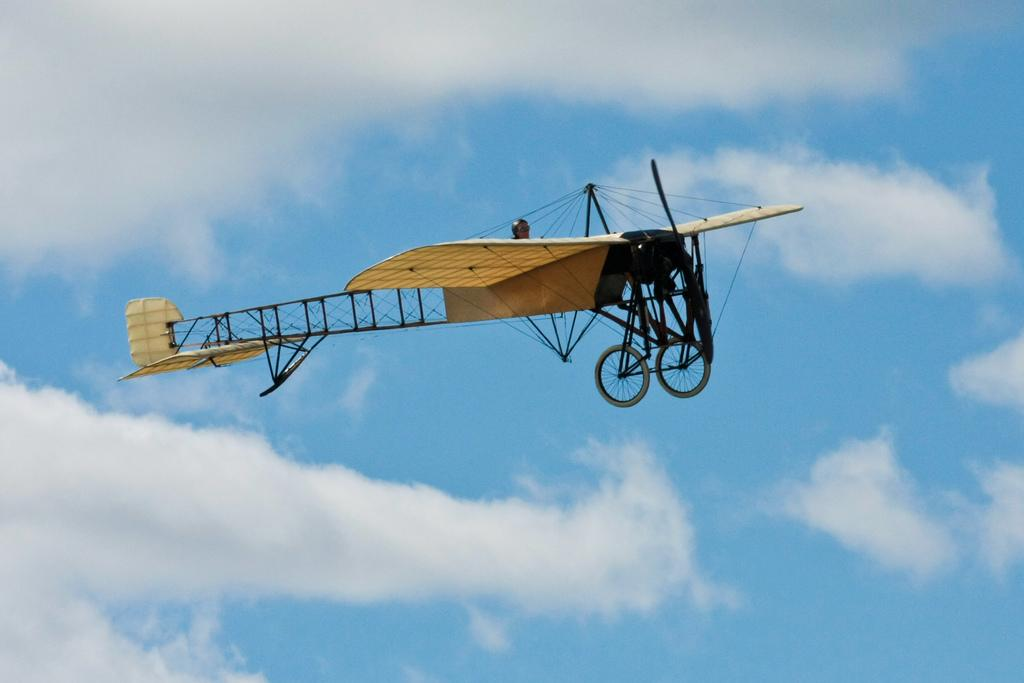What type of aircraft is in the sky in the image? There is a monoplane in the sky in the image. Who is inside the monoplane? There is a person sitting in the monoplane. What can be seen in the background of the image? The sky is visible in the image, and there are clouds in the sky. What type of acoustics can be heard from the queen in the image? There is no queen or acoustics present in the image. 